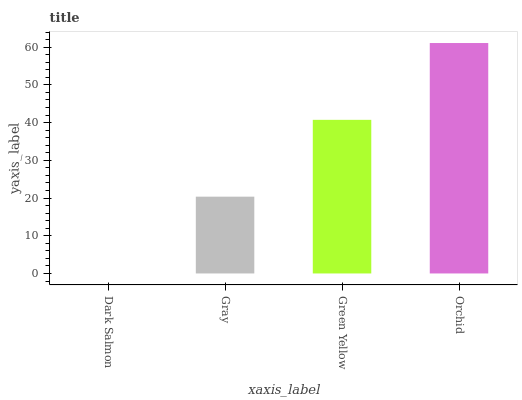Is Dark Salmon the minimum?
Answer yes or no. Yes. Is Orchid the maximum?
Answer yes or no. Yes. Is Gray the minimum?
Answer yes or no. No. Is Gray the maximum?
Answer yes or no. No. Is Gray greater than Dark Salmon?
Answer yes or no. Yes. Is Dark Salmon less than Gray?
Answer yes or no. Yes. Is Dark Salmon greater than Gray?
Answer yes or no. No. Is Gray less than Dark Salmon?
Answer yes or no. No. Is Green Yellow the high median?
Answer yes or no. Yes. Is Gray the low median?
Answer yes or no. Yes. Is Orchid the high median?
Answer yes or no. No. Is Dark Salmon the low median?
Answer yes or no. No. 